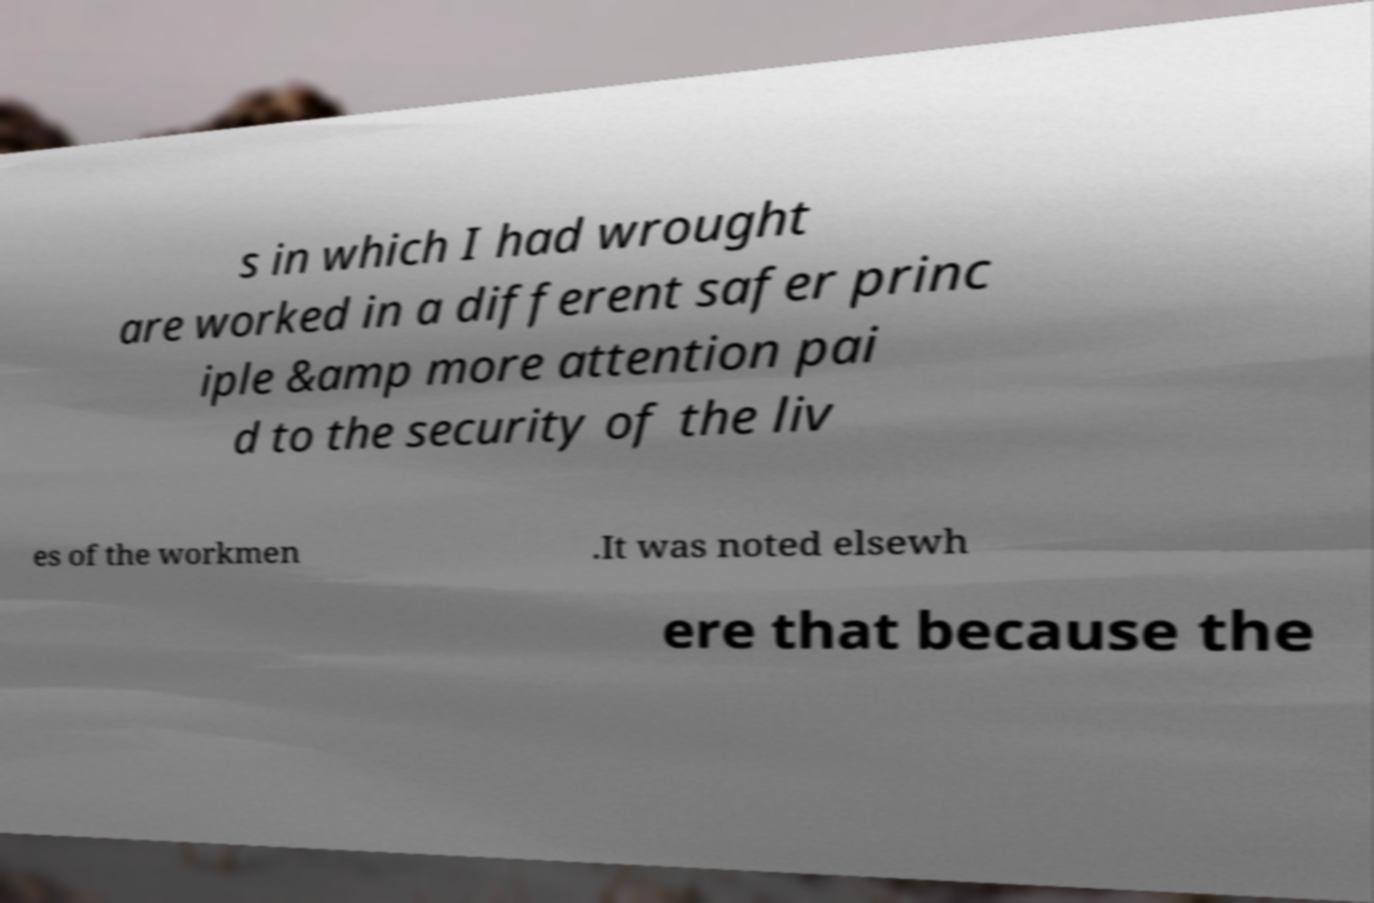Could you assist in decoding the text presented in this image and type it out clearly? s in which I had wrought are worked in a different safer princ iple &amp more attention pai d to the security of the liv es of the workmen .It was noted elsewh ere that because the 